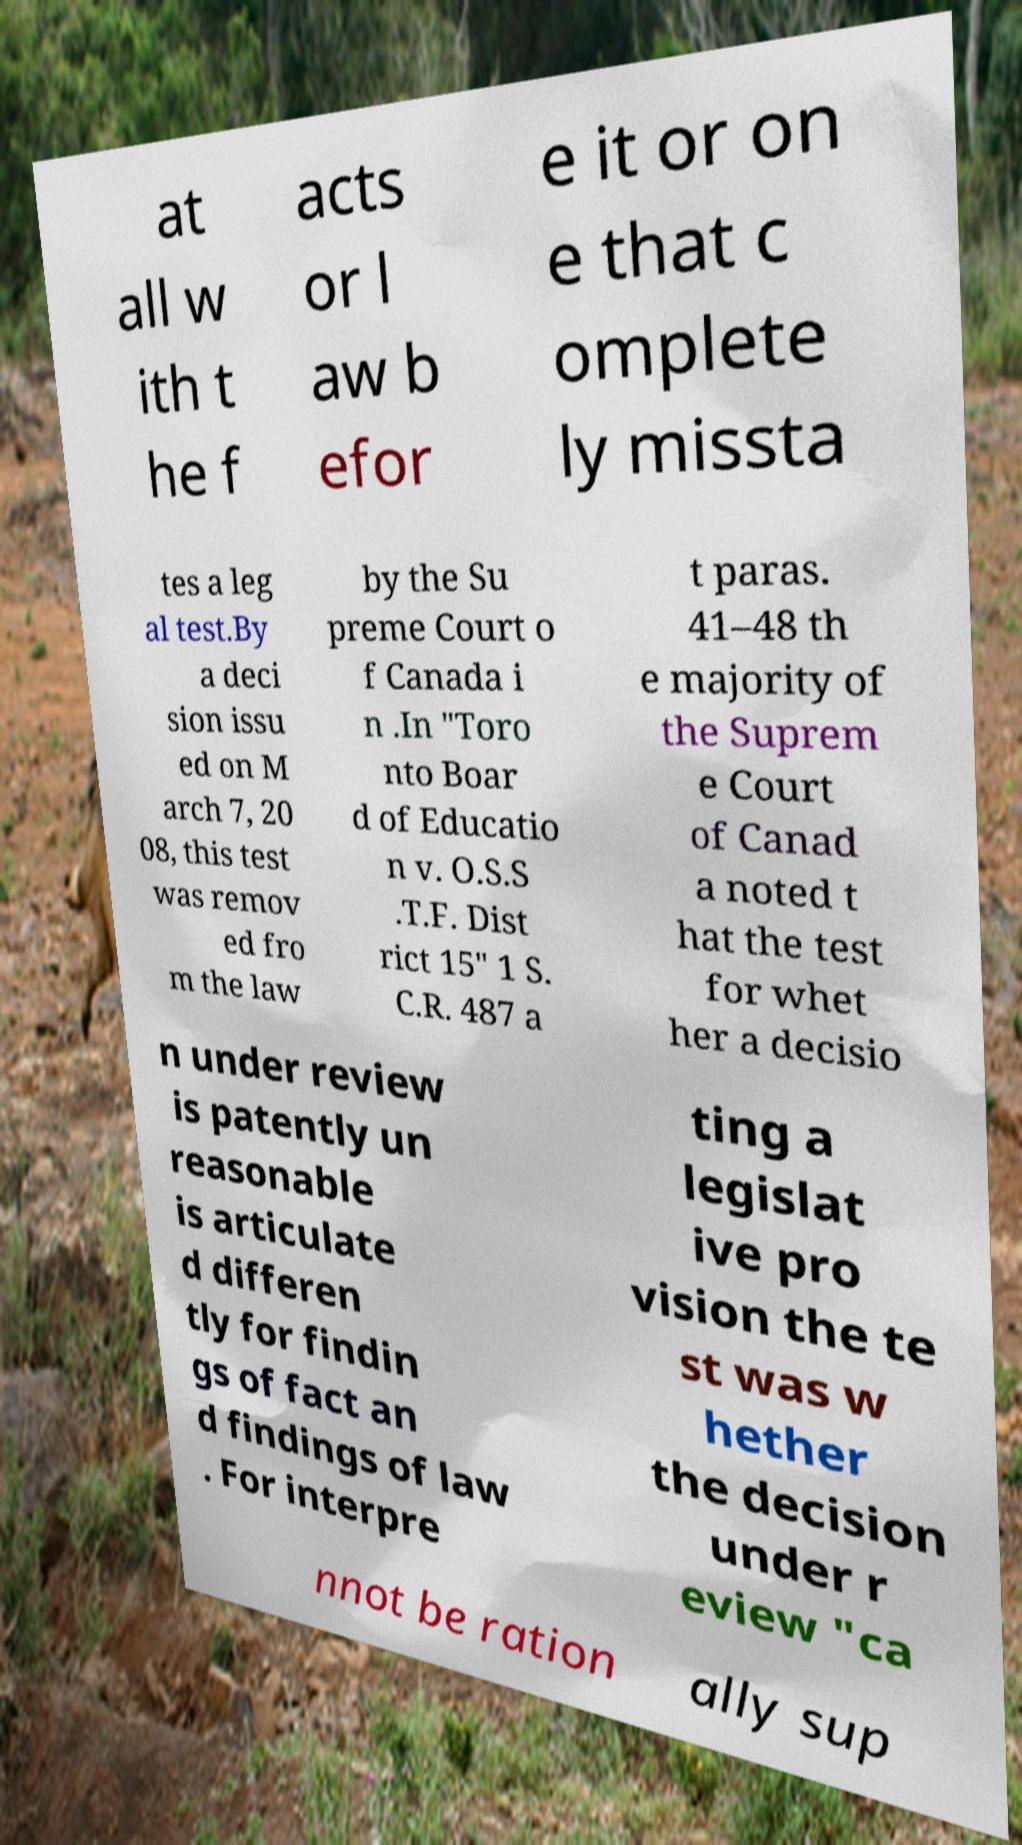Can you read and provide the text displayed in the image?This photo seems to have some interesting text. Can you extract and type it out for me? at all w ith t he f acts or l aw b efor e it or on e that c omplete ly missta tes a leg al test.By a deci sion issu ed on M arch 7, 20 08, this test was remov ed fro m the law by the Su preme Court o f Canada i n .In "Toro nto Boar d of Educatio n v. O.S.S .T.F. Dist rict 15" 1 S. C.R. 487 a t paras. 41–48 th e majority of the Suprem e Court of Canad a noted t hat the test for whet her a decisio n under review is patently un reasonable is articulate d differen tly for findin gs of fact an d findings of law . For interpre ting a legislat ive pro vision the te st was w hether the decision under r eview "ca nnot be ration ally sup 